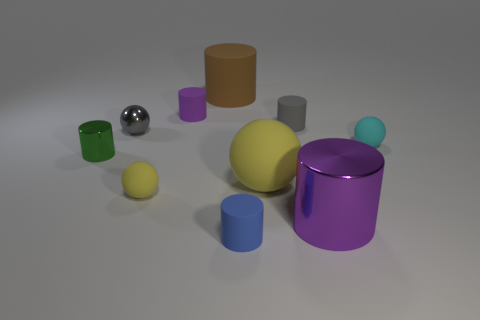Subtract all purple shiny cylinders. How many cylinders are left? 5 Subtract all cyan balls. How many balls are left? 3 Subtract 2 cylinders. How many cylinders are left? 4 Subtract all red cylinders. Subtract all red spheres. How many cylinders are left? 6 Subtract all balls. How many objects are left? 6 Subtract 0 purple cubes. How many objects are left? 10 Subtract all gray rubber objects. Subtract all small yellow matte objects. How many objects are left? 8 Add 7 big purple cylinders. How many big purple cylinders are left? 8 Add 9 tiny blue rubber objects. How many tiny blue rubber objects exist? 10 